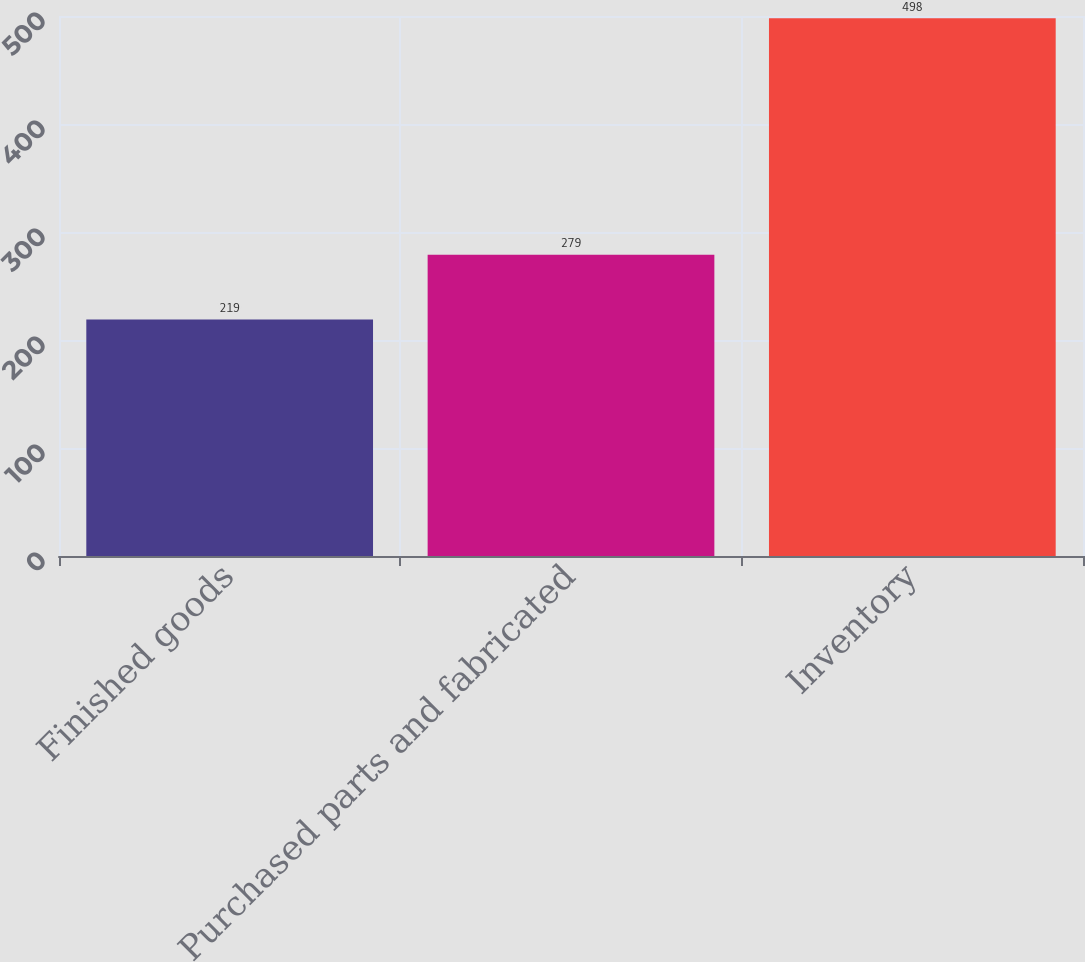Convert chart to OTSL. <chart><loc_0><loc_0><loc_500><loc_500><bar_chart><fcel>Finished goods<fcel>Purchased parts and fabricated<fcel>Inventory<nl><fcel>219<fcel>279<fcel>498<nl></chart> 